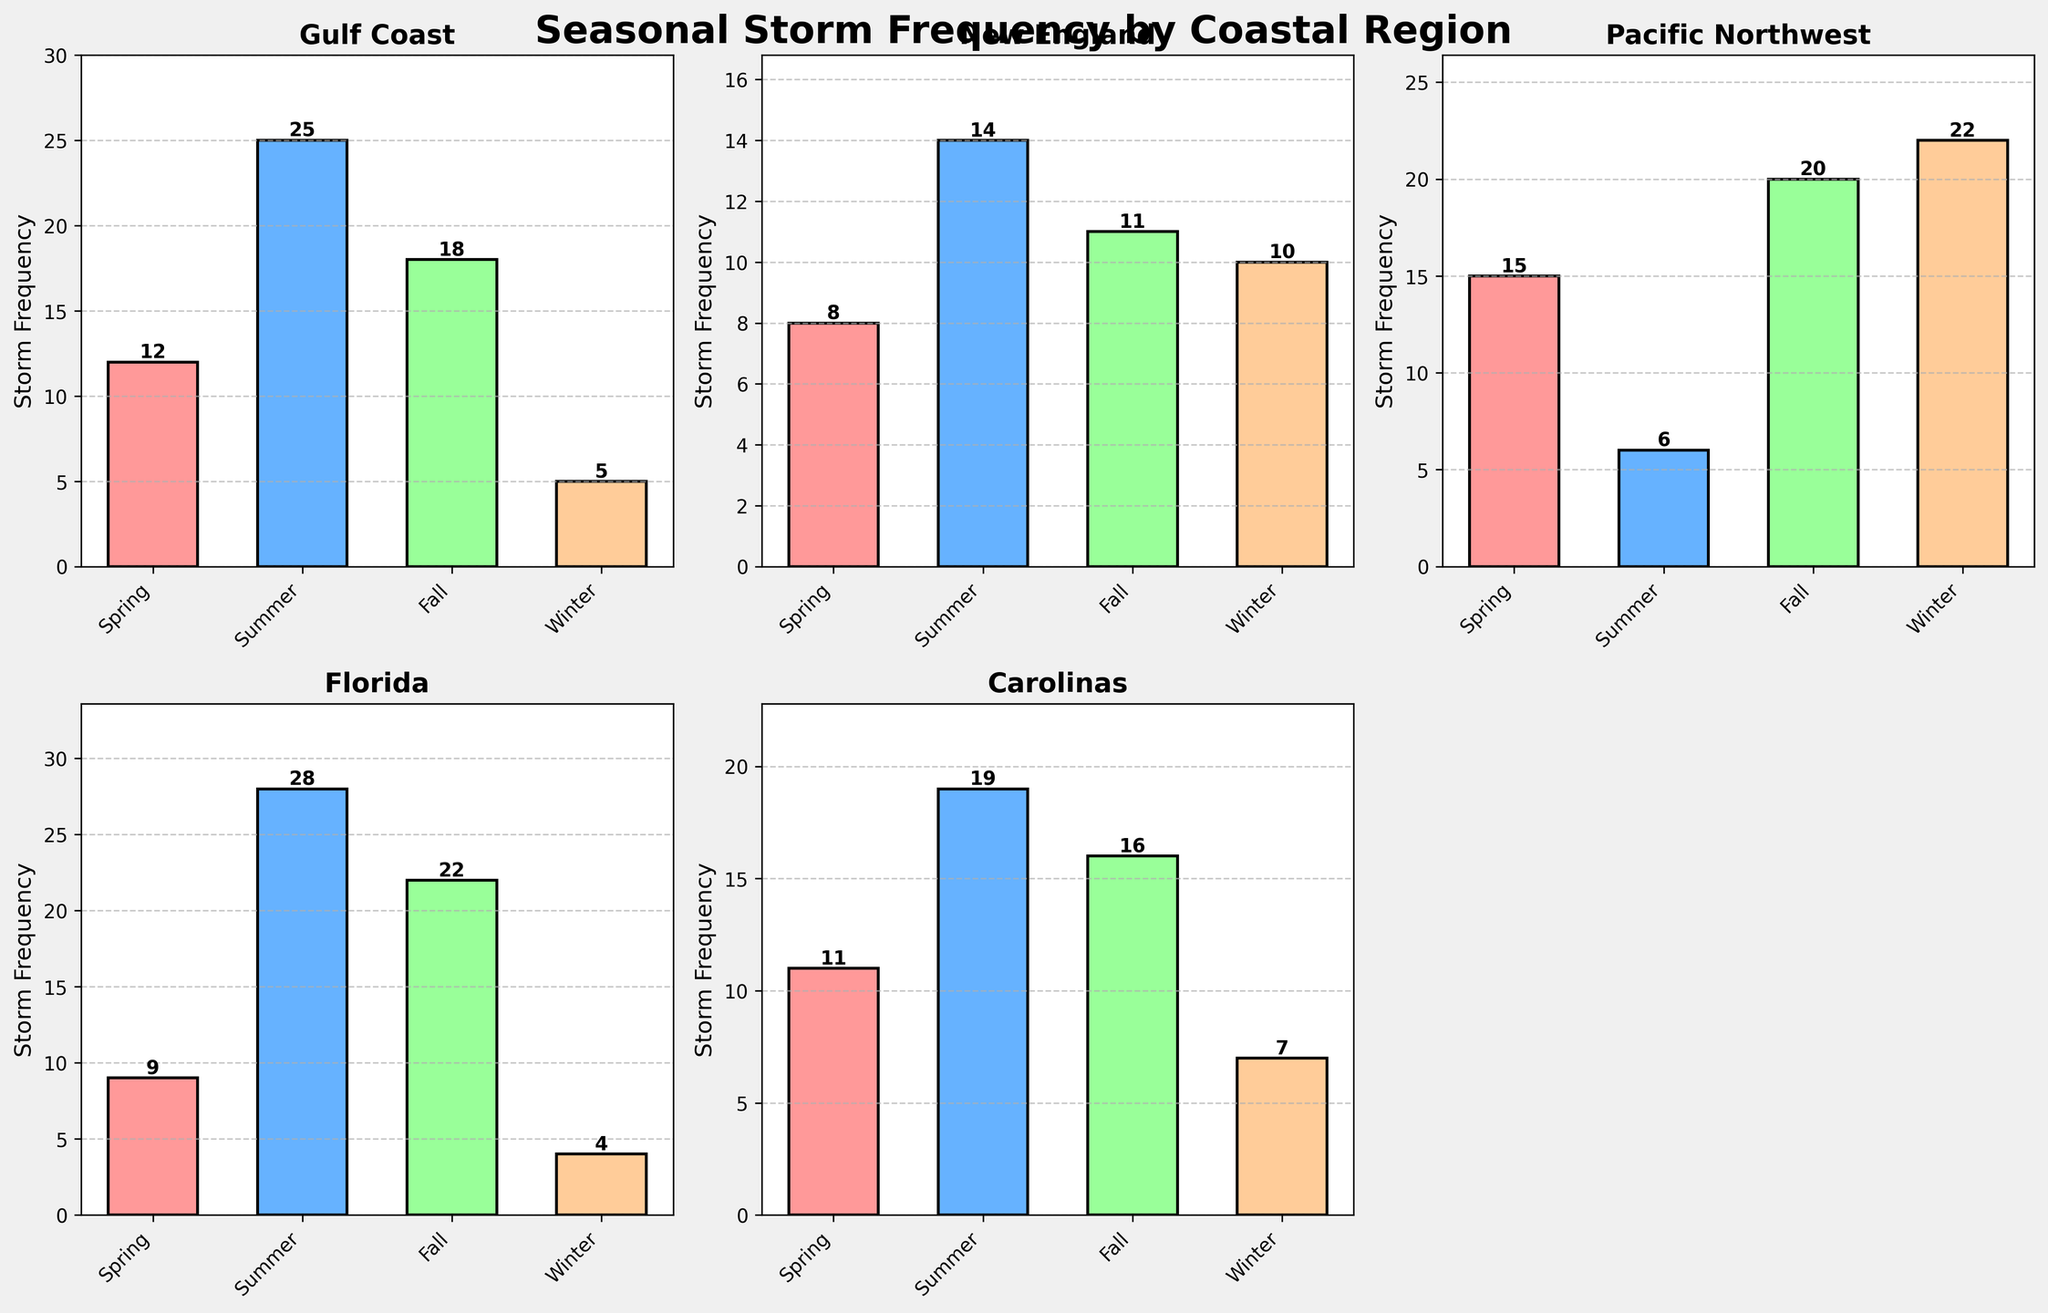Which region experiences the highest storm frequency in winter? Look at the bar corresponding to 'Winter' in each subplot and compare their heights. The Pacific Northwest has the highest bar, indicating the highest storm frequency in winter.
Answer: Pacific Northwest What is the difference in storm frequency between summer and winter for the Gulf Coast? The bar for summer in the Gulf Coast subplot is 25, and for winter, it is 5. The difference is \(25 - 5 = 20\).
Answer: 20 Which season has the lowest storm frequency for Florida? Look at the Florida subplot and find the shortest bar. Winter has the shortest bar with a frequency of 4.
Answer: Winter How does the storm frequency in fall for New England compare to that for the Carolinas? Compare the heights of the bars for 'Fall' in the New England and Carolinas subplots. New England has a frequency of 11, while the Carolinas have 16. The Carolinas have a higher frequency.
Answer: Carolinas What is the average storm frequency across all regions in Summer? Sum the storm frequencies in Summer for all regions and divide by the number of regions. \(25 (Gulf Coast) + 14 (New England) + 6 (Pacific Northwest) + 28 (Florida) + 19 (Carolinas)\) gives a total of 92. The average is \(92 / 5 = 18.4\).
Answer: 18.4 Which region has the smallest variation in storm frequency across the seasons? Compare the range of storm frequencies (difference between highest and lowest values) for each region. The New England region has the least variation, with frequencies ranging from 8 to 14, giving a range of \(14 - 8 = 6\).
Answer: New England What is the total storm frequency for the Pacific Northwest across all seasons? Sum the storm frequencies for all seasons in the Pacific Northwest subplot. \(15 (Spring) + 6 (Summer) + 20 (Fall) + 22 (Winter)\) gives a total of 63.
Answer: 63 Which season generally shows the highest storm frequency across all regions? Compare the bars for each season across all subplots. Summer generally shows the highest storm frequency in the majority of regions.
Answer: Summer 